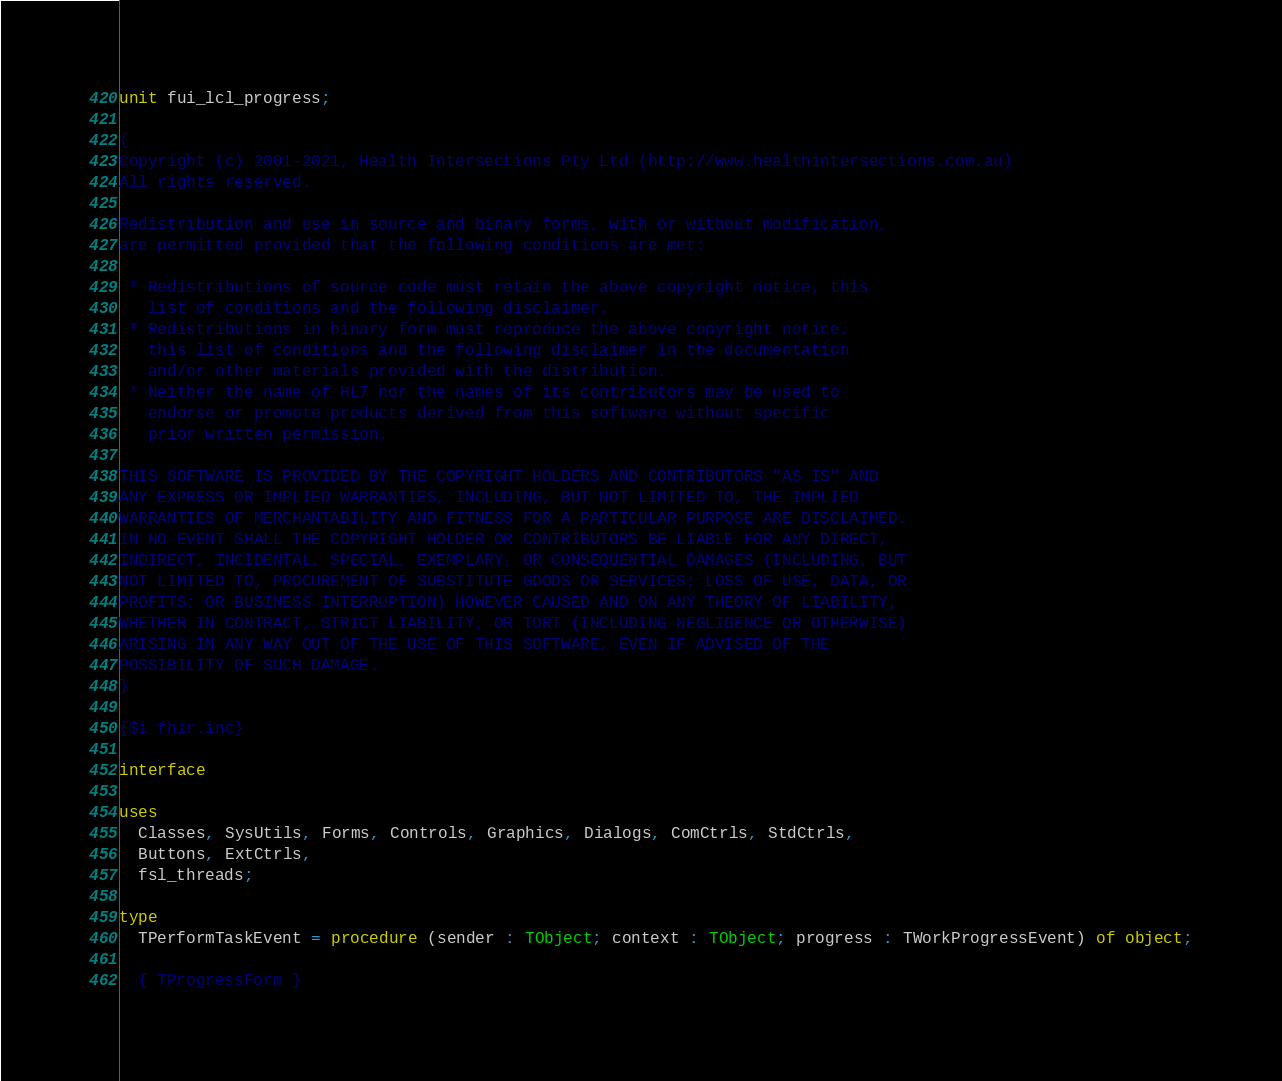<code> <loc_0><loc_0><loc_500><loc_500><_Pascal_>unit fui_lcl_progress;

{
Copyright (c) 2001-2021, Health Intersections Pty Ltd (http://www.healthintersections.com.au)
All rights reserved.

Redistribution and use in source and binary forms, with or without modification,
are permitted provided that the following conditions are met:

 * Redistributions of source code must retain the above copyright notice, this
   list of conditions and the following disclaimer.
 * Redistributions in binary form must reproduce the above copyright notice,
   this list of conditions and the following disclaimer in the documentation
   and/or other materials provided with the distribution.
 * Neither the name of HL7 nor the names of its contributors may be used to
   endorse or promote products derived from this software without specific
   prior written permission.

THIS SOFTWARE IS PROVIDED BY THE COPYRIGHT HOLDERS AND CONTRIBUTORS "AS IS" AND
ANY EXPRESS OR IMPLIED WARRANTIES, INCLUDING, BUT NOT LIMITED TO, THE IMPLIED
WARRANTIES OF MERCHANTABILITY AND FITNESS FOR A PARTICULAR PURPOSE ARE DISCLAIMED.
IN NO EVENT SHALL THE COPYRIGHT HOLDER OR CONTRIBUTORS BE LIABLE FOR ANY DIRECT,
INDIRECT, INCIDENTAL, SPECIAL, EXEMPLARY, OR CONSEQUENTIAL DAMAGES (INCLUDING, BUT
NOT LIMITED TO, PROCUREMENT OF SUBSTITUTE GOODS OR SERVICES; LOSS OF USE, DATA, OR
PROFITS; OR BUSINESS INTERRUPTION) HOWEVER CAUSED AND ON ANY THEORY OF LIABILITY,
WHETHER IN CONTRACT, STRICT LIABILITY, OR TORT (INCLUDING NEGLIGENCE OR OTHERWISE)
ARISING IN ANY WAY OUT OF THE USE OF THIS SOFTWARE, EVEN IF ADVISED OF THE
POSSIBILITY OF SUCH DAMAGE.
}

{$i fhir.inc}

interface

uses
  Classes, SysUtils, Forms, Controls, Graphics, Dialogs, ComCtrls, StdCtrls,
  Buttons, ExtCtrls,
  fsl_threads;

type
  TPerformTaskEvent = procedure (sender : TObject; context : TObject; progress : TWorkProgressEvent) of object;

  { TProgressForm }</code> 